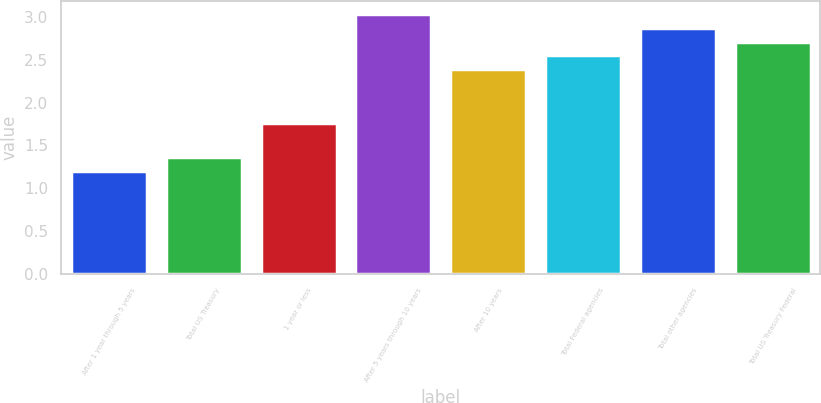<chart> <loc_0><loc_0><loc_500><loc_500><bar_chart><fcel>After 1 year through 5 years<fcel>Total US Treasury<fcel>1 year or less<fcel>After 5 years through 10 years<fcel>After 10 years<fcel>Total Federal agencies<fcel>Total other agencies<fcel>Total US Treasury Federal<nl><fcel>1.2<fcel>1.36<fcel>1.76<fcel>3.03<fcel>2.39<fcel>2.55<fcel>2.87<fcel>2.71<nl></chart> 